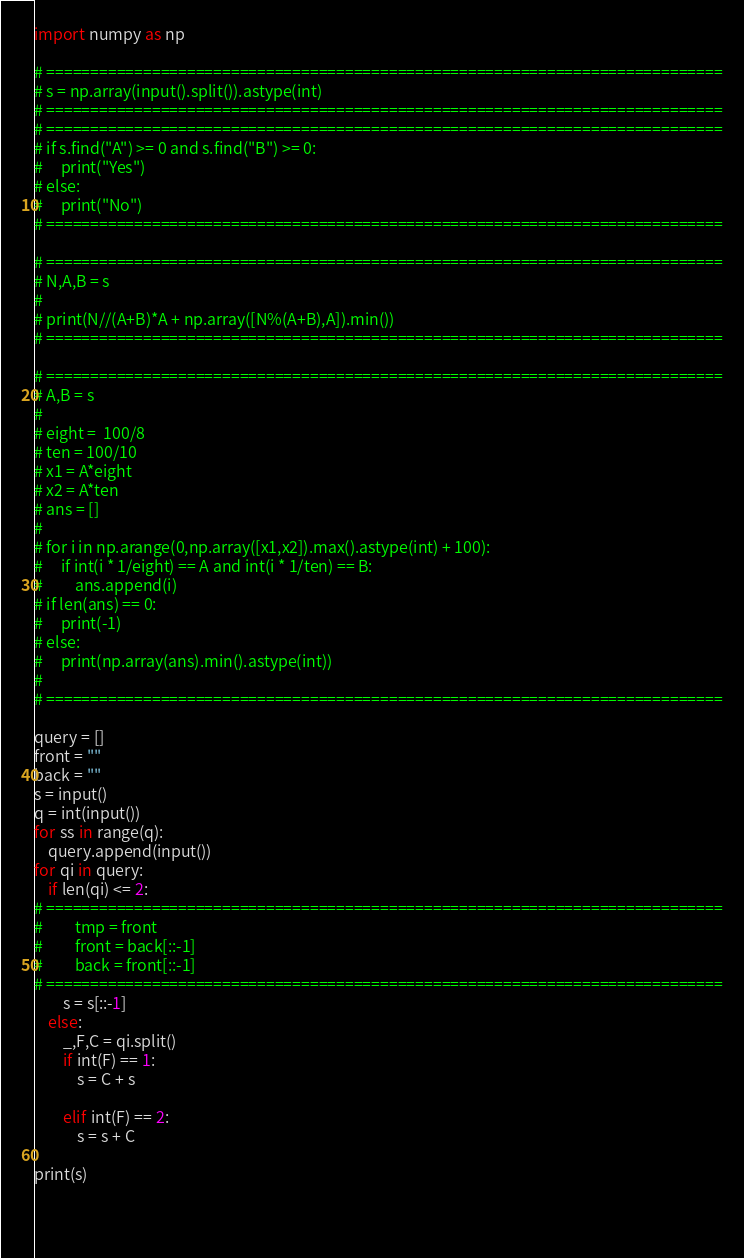Convert code to text. <code><loc_0><loc_0><loc_500><loc_500><_Python_>import numpy as np

# =============================================================================
# s = np.array(input().split()).astype(int)
# =============================================================================
# =============================================================================
# if s.find("A") >= 0 and s.find("B") >= 0:
#     print("Yes")
# else:
#     print("No")
# =============================================================================

# =============================================================================
# N,A,B = s
# 
# print(N//(A+B)*A + np.array([N%(A+B),A]).min())
# =============================================================================

# =============================================================================
# A,B = s
# 
# eight =  100/8
# ten = 100/10
# x1 = A*eight
# x2 = A*ten
# ans = []
# 
# for i in np.arange(0,np.array([x1,x2]).max().astype(int) + 100):
#     if int(i * 1/eight) == A and int(i * 1/ten) == B:
#         ans.append(i)
# if len(ans) == 0:
#     print(-1)
# else:
#     print(np.array(ans).min().astype(int))
# 
# =============================================================================

query = []
front = ""
back = ""
s = input()
q = int(input())
for ss in range(q):
    query.append(input())
for qi in query:
    if len(qi) <= 2:
# =============================================================================
#         tmp = front
#         front = back[::-1]
#         back = front[::-1]
# =============================================================================
        s = s[::-1]
    else:
        _,F,C = qi.split()
        if int(F) == 1:
            s = C + s
          
        elif int(F) == 2:
            s = s + C
            
print(s)
        
        
    
</code> 